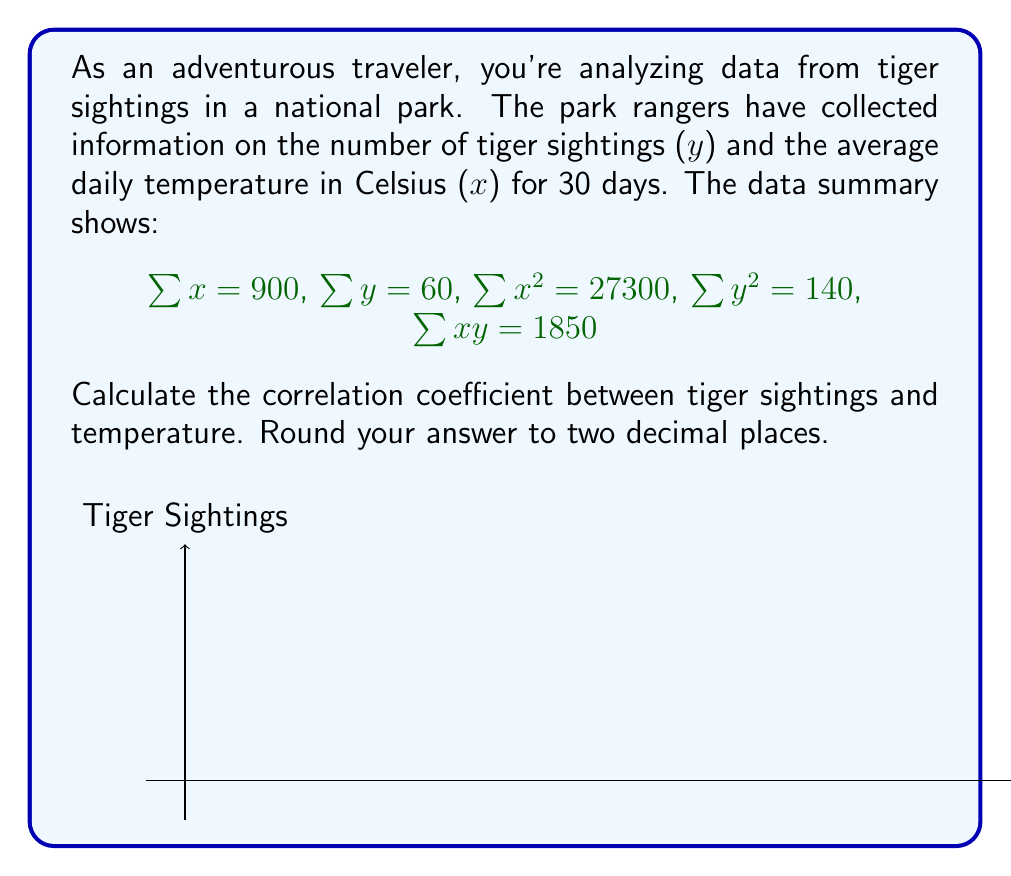Give your solution to this math problem. To calculate the correlation coefficient, we'll use the formula:

$$r = \frac{n\sum xy - \sum x \sum y}{\sqrt{[n\sum x^2 - (\sum x)^2][n\sum y^2 - (\sum y)^2]}}$$

Where n is the number of data points (30 in this case).

Step 1: Calculate $n\sum xy - \sum x \sum y$
$$30 * 1850 - 900 * 60 = 55500 - 54000 = 1500$$

Step 2: Calculate $n\sum x^2 - (\sum x)^2$
$$30 * 27300 - 900^2 = 819000 - 810000 = 9000$$

Step 3: Calculate $n\sum y^2 - (\sum y)^2$
$$30 * 140 - 60^2 = 4200 - 3600 = 600$$

Step 4: Multiply the results from steps 2 and 3
$$9000 * 600 = 5400000$$

Step 5: Take the square root of step 4
$$\sqrt{5400000} = 2323.79$$

Step 6: Divide the result from step 1 by the result from step 5
$$\frac{1500}{2323.79} = 0.6455$$

Step 7: Round to two decimal places
$$0.65$$
Answer: 0.65 